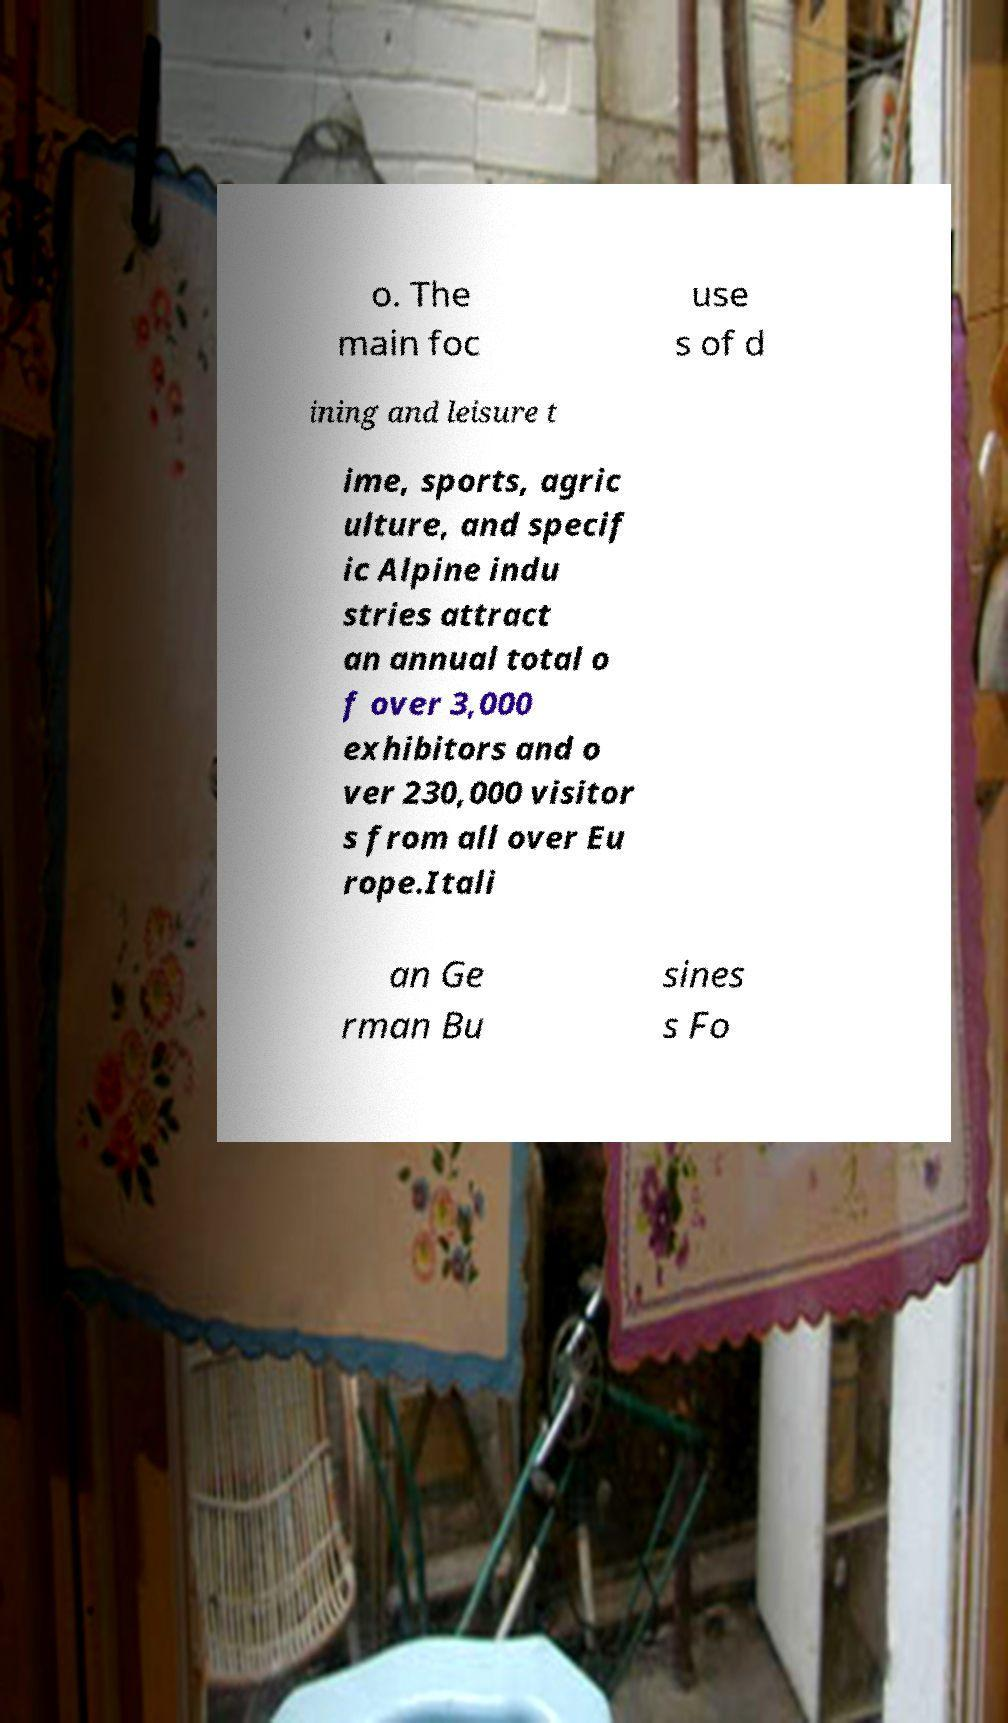There's text embedded in this image that I need extracted. Can you transcribe it verbatim? o. The main foc use s of d ining and leisure t ime, sports, agric ulture, and specif ic Alpine indu stries attract an annual total o f over 3,000 exhibitors and o ver 230,000 visitor s from all over Eu rope.Itali an Ge rman Bu sines s Fo 